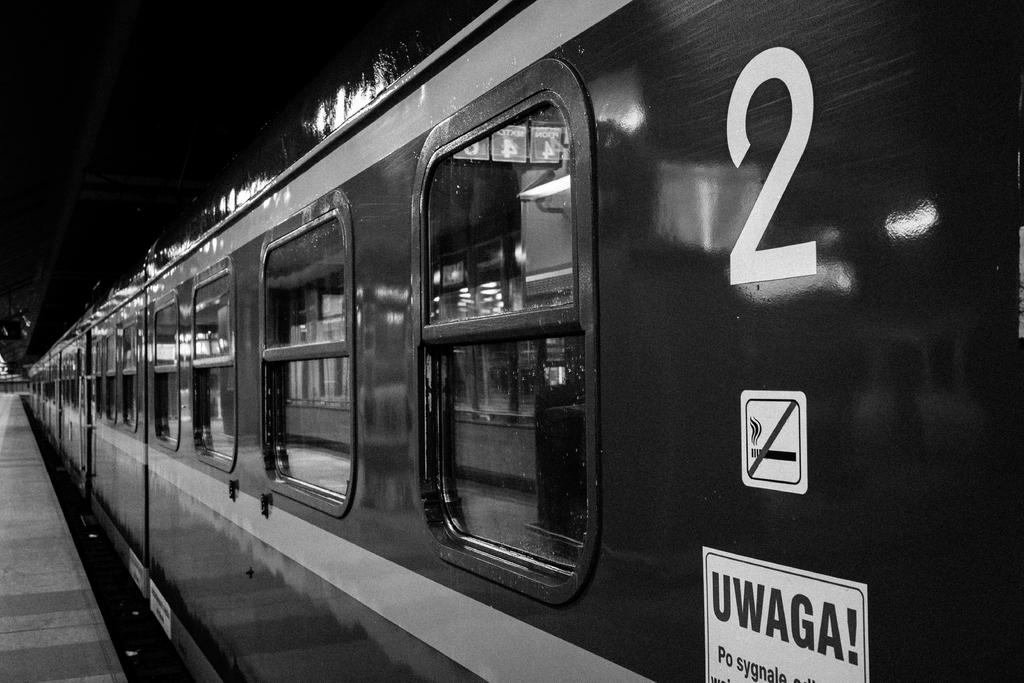<image>
Provide a brief description of the given image. a train that has the number 2 on it 